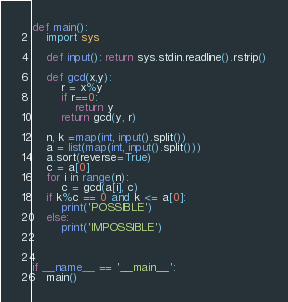Convert code to text. <code><loc_0><loc_0><loc_500><loc_500><_Python_>def main():
    import sys

    def input(): return sys.stdin.readline().rstrip()

    def gcd(x,y):
        r = x%y
        if r==0:
            return y
        return gcd(y, r)

    n, k =map(int, input().split())
    a = list(map(int, input().split()))
    a.sort(reverse=True)
    c = a[0]
    for i in range(n):
        c = gcd(a[i], c)
    if k%c == 0 and k <= a[0]:
        print('POSSIBLE')
    else:
        print('IMPOSSIBLE')
    

    
if __name__ == '__main__':
    main()</code> 